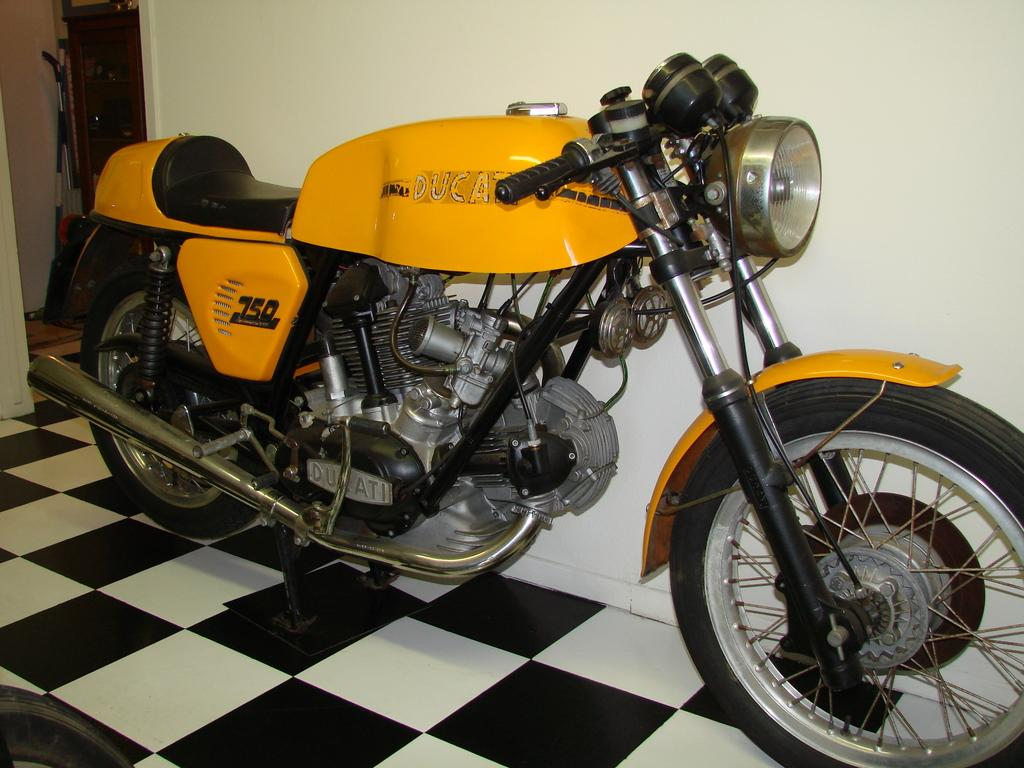What color is the bike in the image? The bike in the image is yellow. Is there any text or design on the bike? Yes, something is written on the bike. What can be seen in the background of the image? There is a wall in the background of the image. How would you describe the floor pattern in the image? The floor has a black and white check pattern. Can you describe any additional items visible in the background? There are some items in the background of the image. What type of calculator is the farmer using to lift the bike in the image? There is no calculator, farmer, or lifting action depicted in the image; it features a yellow bike with something written on it, a wall in the background, a black and white checkered floor, and some additional items in the background. 